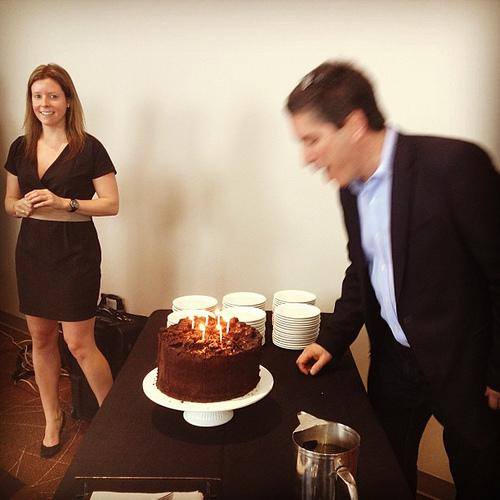Question: what is on the cake?
Choices:
A. Icing.
B. Frosting and candles.
C. Sprinkles.
D. Fondant.
Answer with the letter. Answer: B Question: where is the cake plate?
Choices:
A. On the counter.
B. On the table.
C. On the desk.
D. In the fridge.
Answer with the letter. Answer: B Question: who is blowing out the candles?
Choices:
A. The woman.
B. The boy.
C. The girl.
D. The man.
Answer with the letter. Answer: D Question: how will the cake be served?
Choices:
A. With a spatula.
B. On those plates.
C. At the table.
D. After the candles are blown out.
Answer with the letter. Answer: B Question: what color is the cake?
Choices:
A. White.
B. Brown.
C. Yellow.
D. Blue and white.
Answer with the letter. Answer: B Question: what is on the man's head?
Choices:
A. A baseball hat.
B. A visor.
C. A bandanna.
D. Sunglasses.
Answer with the letter. Answer: D 